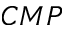Convert formula to latex. <formula><loc_0><loc_0><loc_500><loc_500>C M P</formula> 